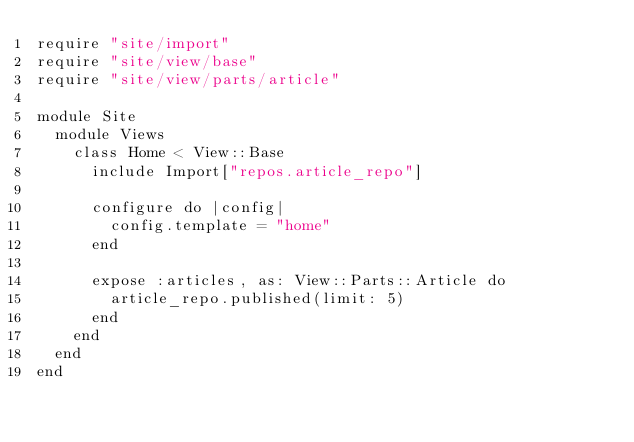<code> <loc_0><loc_0><loc_500><loc_500><_Ruby_>require "site/import"
require "site/view/base"
require "site/view/parts/article"

module Site
  module Views
    class Home < View::Base
      include Import["repos.article_repo"]

      configure do |config|
        config.template = "home"
      end

      expose :articles, as: View::Parts::Article do
        article_repo.published(limit: 5)
      end
    end
  end
end
</code> 